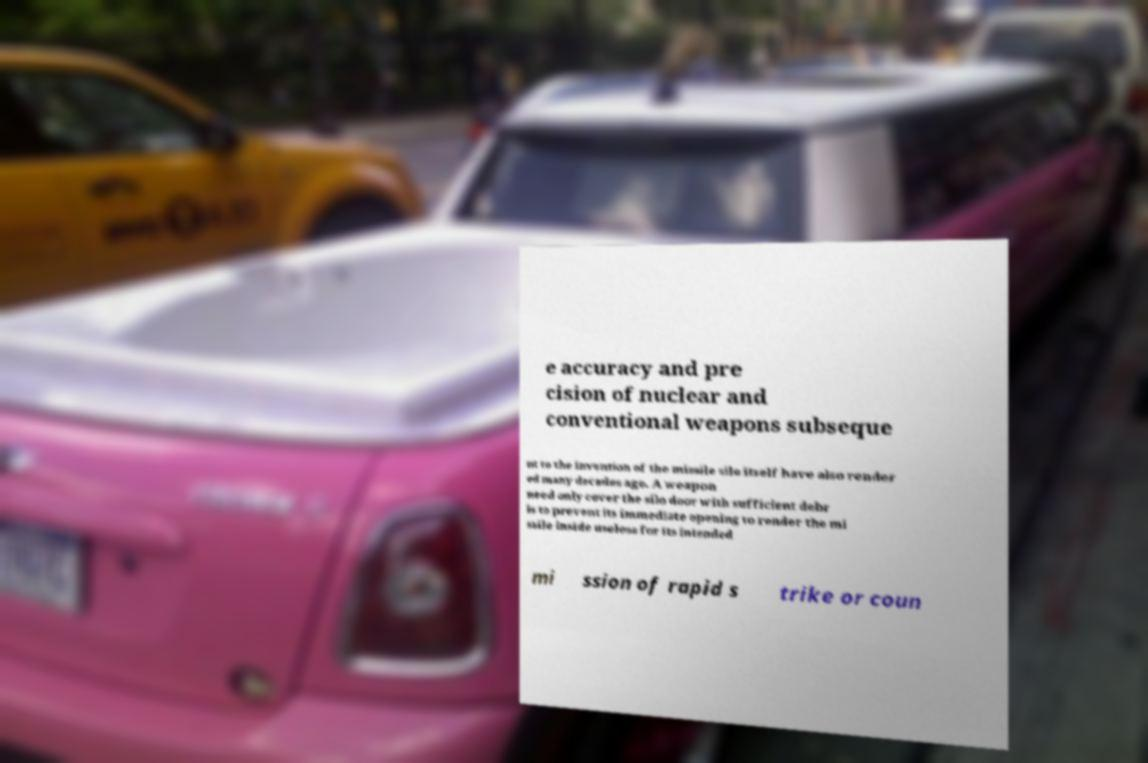Can you accurately transcribe the text from the provided image for me? e accuracy and pre cision of nuclear and conventional weapons subseque nt to the invention of the missile silo itself have also render ed many decades ago. A weapon need only cover the silo door with sufficient debr is to prevent its immediate opening to render the mi ssile inside useless for its intended mi ssion of rapid s trike or coun 